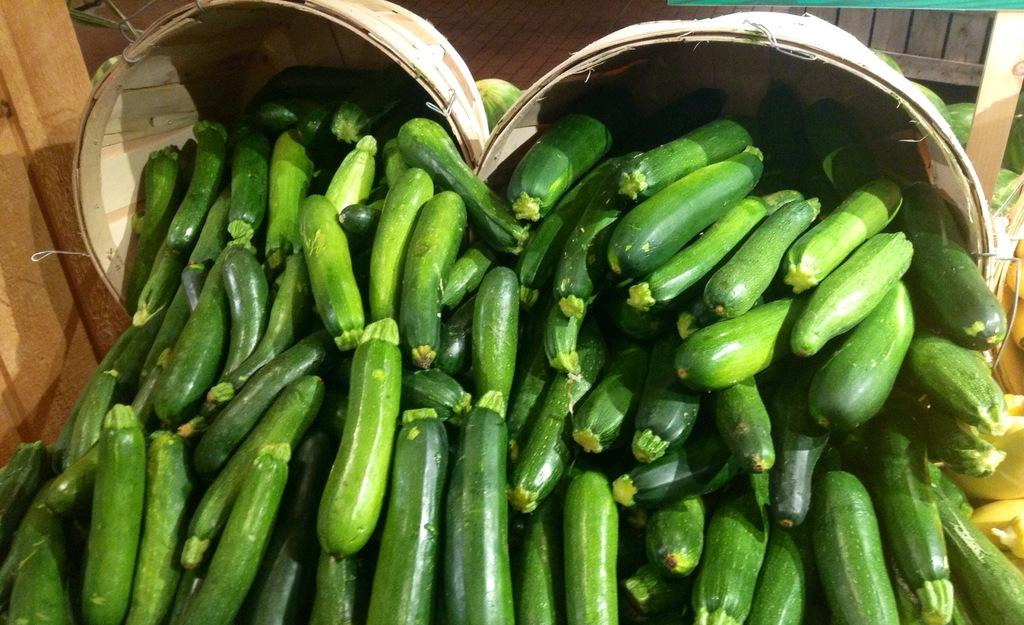What type of vegetable is present in the image? There are cucumbers in the image. What objects are used for carrying or holding items in the image? There are baskets in the image. What type of cup is being used to hold the cucumbers in the image? There is no cup present in the image; the cucumbers are not being held in a cup. 